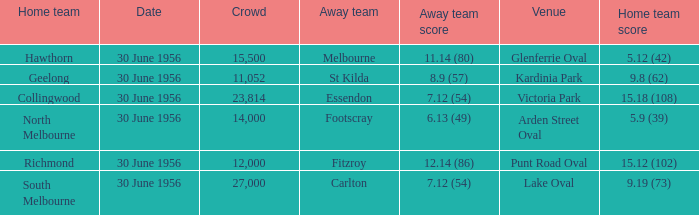What away team has a home team score of 15.18 (108)? Essendon. 